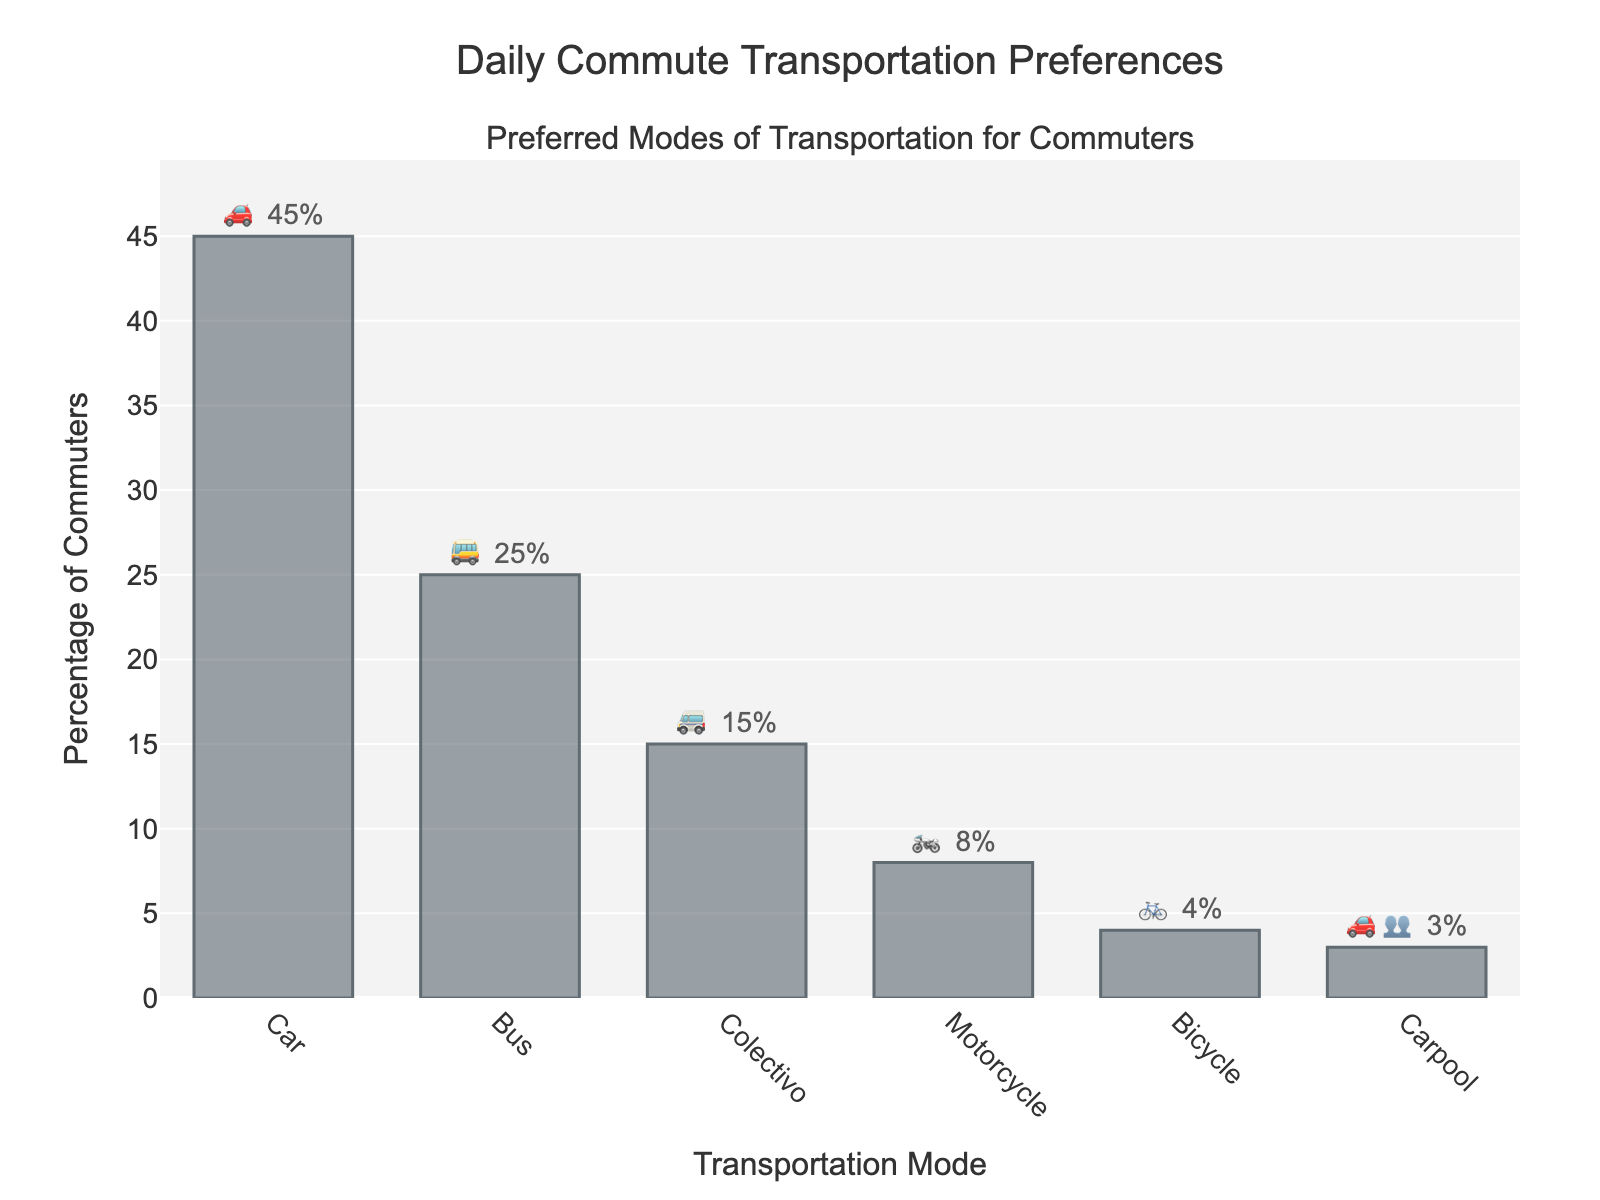What is the most preferred mode of transportation for commuters? The bar with the highest percentage represents the most preferred mode of transportation. The Car (🚗) bar is the tallest at 45%.
Answer: Car What percentage of commuters use motorcycles (🏍️)? Look at the bar representing motorcycles and read the percentage displayed or indicated in the tooltip/label. The Motorcycle (🏍️) bar shows 8%.
Answer: 8% Which mode of transportation is used by the least percentage of commuters? Identify the bar with the shortest height or lowest value. The Carpool (🚗👥) bar is the shortest, representing 3%.
Answer: Carpool How much higher is the percentage of Car (🚗) users compared to Bus (🚌) users? Subtract the percentage of Bus (🚌) users from the percentage of Car (🚗) users: 45% - 25% = 20%.
Answer: 20% What is the total percentage of commuters using Colectivo (🚐) and Bicycle (🚲)? Sum the percentages of Colectivo (🚐) and Bicycle (🚲) users: 15% + 4% = 19%.
Answer: 19% What is the combined percentage of commuters using either a Car (🚗) or Carpool (🚗👥)? Add the percentages of Car (🚗) and Carpool (🚗👥) users: 45% + 3% = 48%.
Answer: 48% Which mode of transportation rank is third in terms of percentage use? Look at the bar heights and labels to determine the third-highest percentage. Car (45%), Bus (25%), Colectivo (15%)—the third is Colectivo (🚐).
Answer: Colectivo Do more people use buses (🚌) or motorcycles (🏍️) for commuting? Compare the percentage values of Bus (🚌) and Motorcycle (🏍️). Bus has 25%, and Motorcycle has 8%, so more people use buses.
Answer: Bus What is the average percentage of commuters using Car (🚗), Bus (🚌), and Colectivo (🚐)? Sum the percentages of Car (🚗), Bus (🚌), and Colectivo (🚐) and divide by 3: (45% + 25% + 15%) / 3 = 28.33%.
Answer: 28.33% How many more percentage points do Car (🚗) users represent compared to all other modes combined? The total percentage is 100%. Subtract the percentage of Car users from 100%: 100% - 45% = 55%.
Answer: 55% 